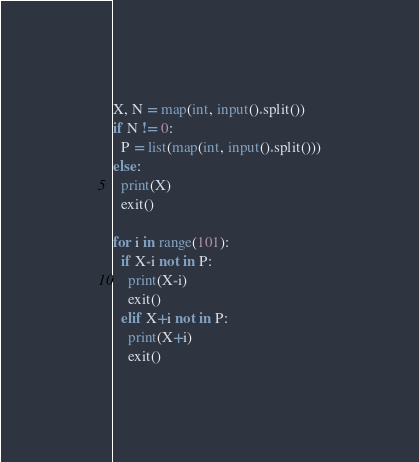Convert code to text. <code><loc_0><loc_0><loc_500><loc_500><_Python_>X, N = map(int, input().split())
if N != 0:
  P = list(map(int, input().split()))
else:
  print(X)
  exit()

for i in range(101):
  if X-i not in P:
    print(X-i)
    exit()
  elif X+i not in P:
    print(X+i)
    exit()</code> 